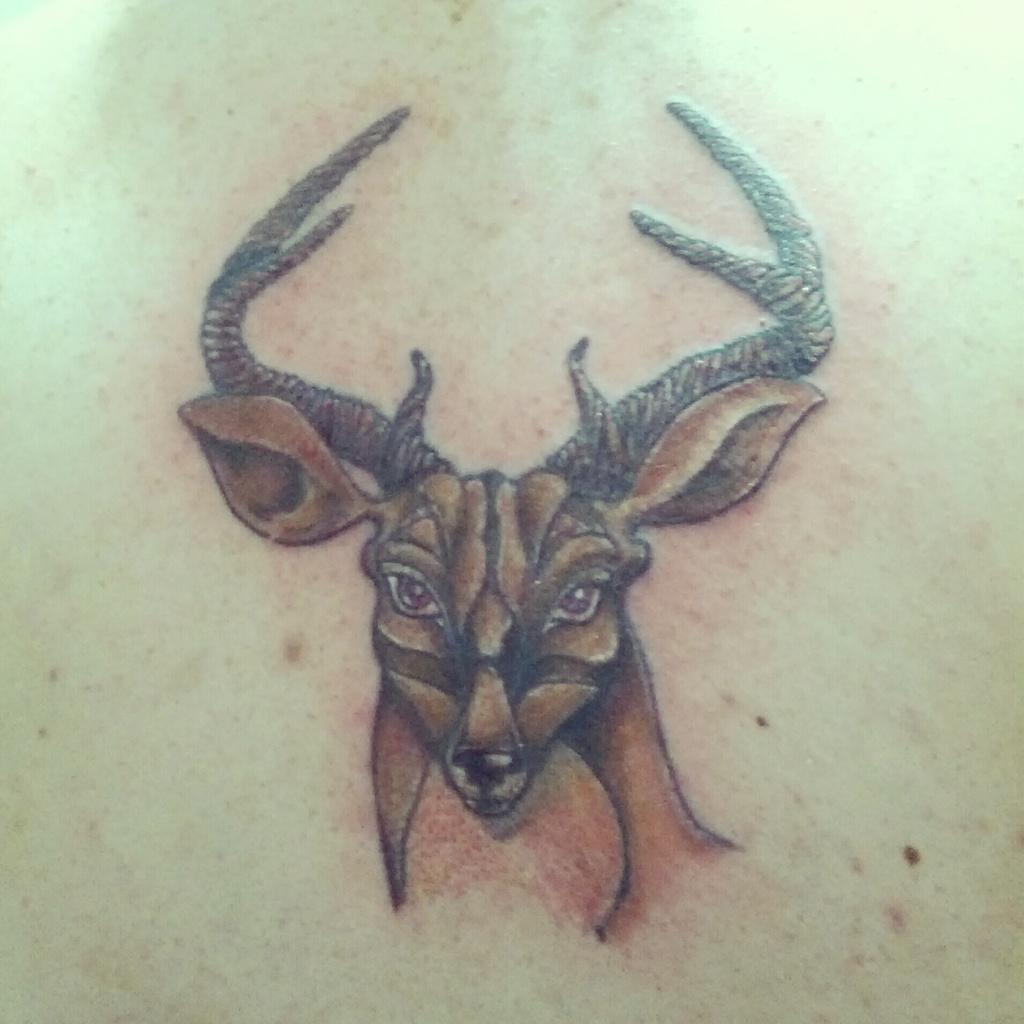What type of animal is present in the image? There is a brown deer in the image. What is the name of the mother deer in the image? There is no mother deer mentioned in the image, as only one brown deer is present. 